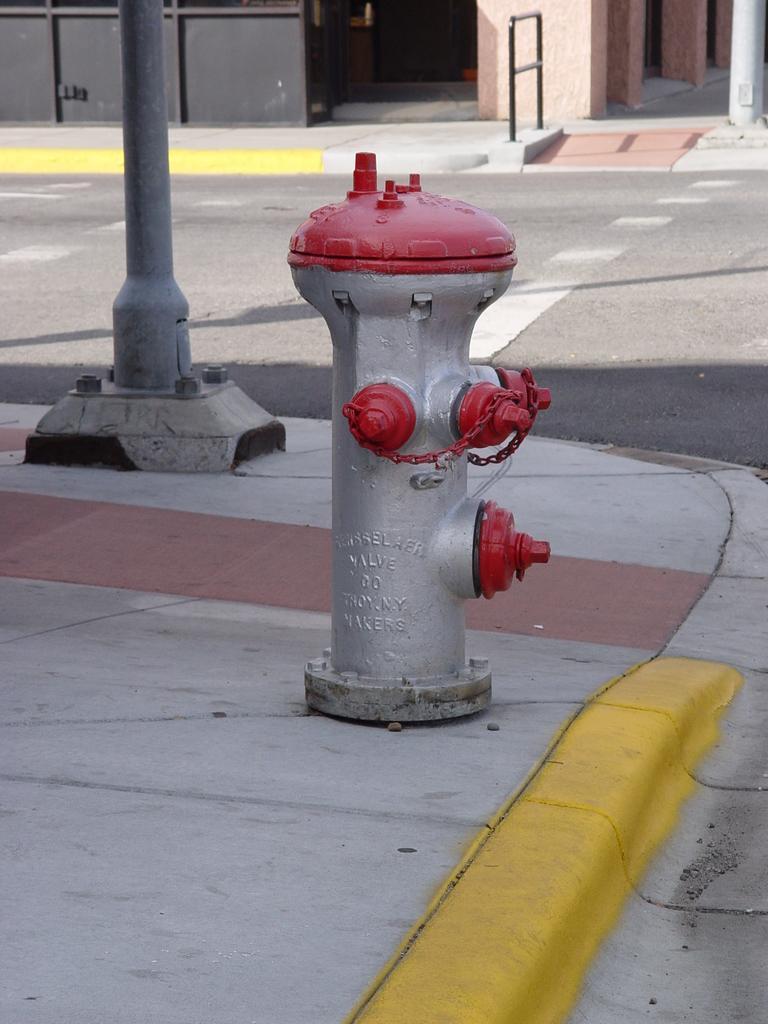In one or two sentences, can you explain what this image depicts? In this picture I can see a fire hydrant and a pole on the side walk and looks like a building in the background. 